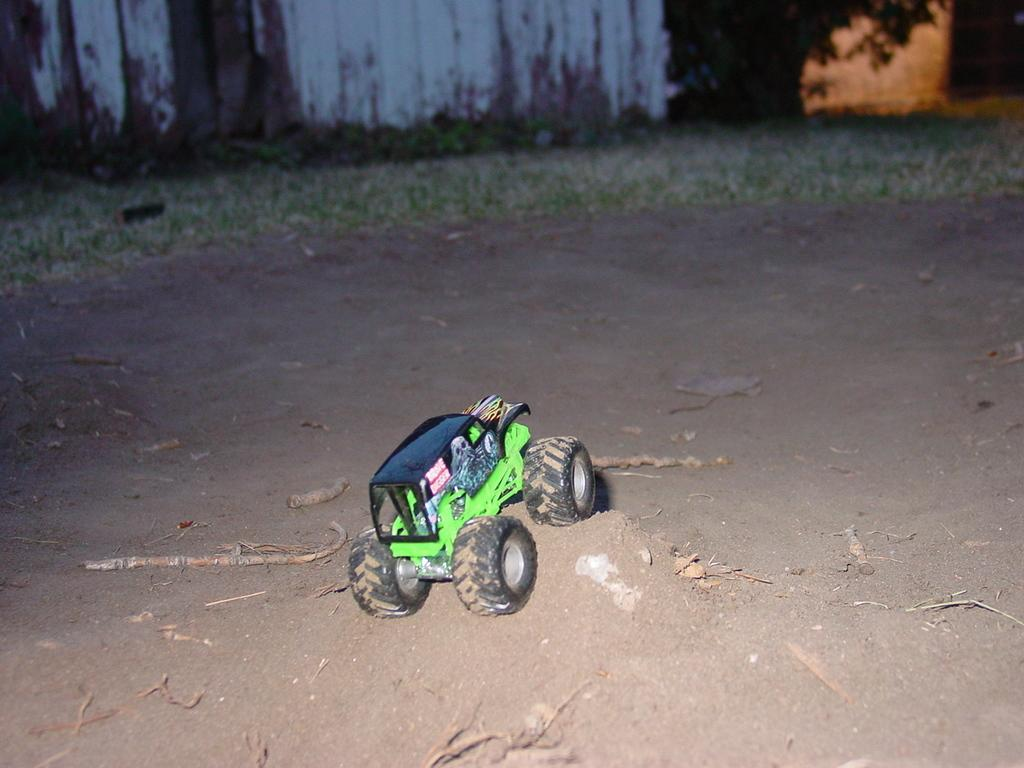What is the main object in the image? There is a truck toy in the image. Where is the truck toy located? The truck toy is on the sand. What can be seen in the background of the image? There is a building's wall and grass visible in the background. What is causing the truck toy to make a throaty sound in the image? There is no indication in the image that the truck toy is making any sound, let alone a throaty sound. 